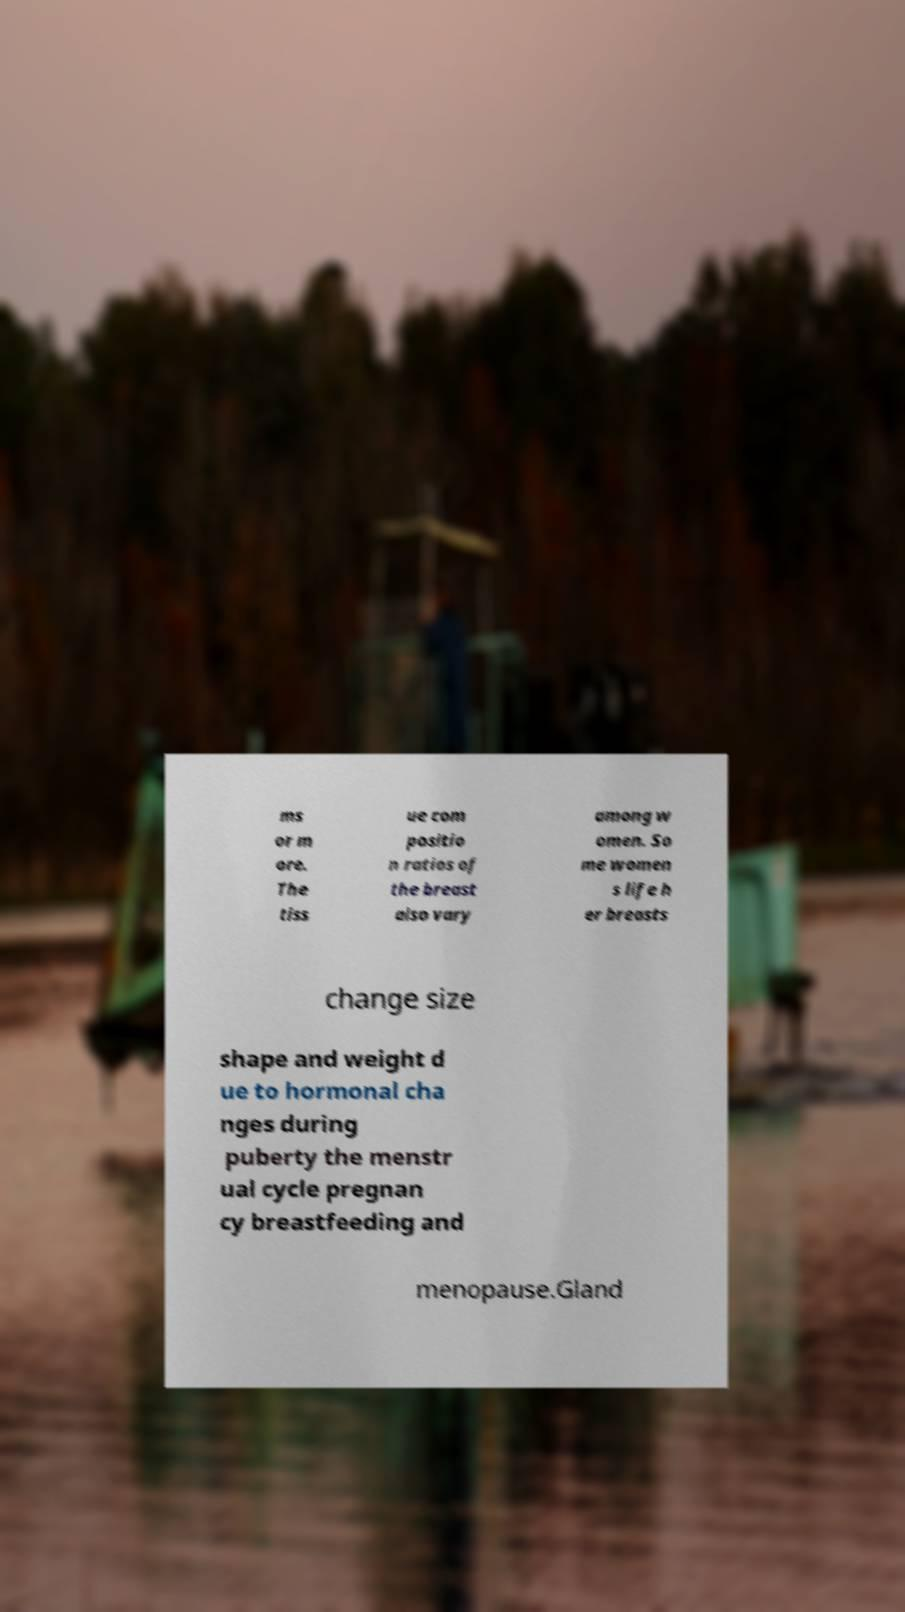Please identify and transcribe the text found in this image. ms or m ore. The tiss ue com positio n ratios of the breast also vary among w omen. So me women s life h er breasts change size shape and weight d ue to hormonal cha nges during puberty the menstr ual cycle pregnan cy breastfeeding and menopause.Gland 